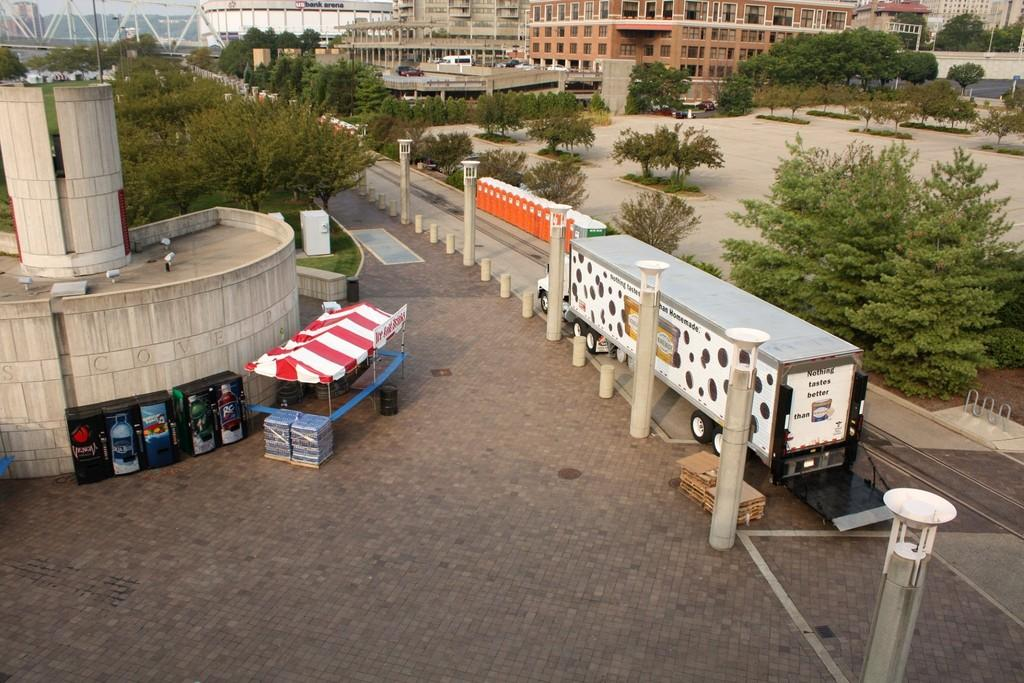What is happening in the image? There is a vehicle moving on the road in the image. What can be seen in the image besides the vehicle? There is a red tent, black color objects, trees, a building, and poles in the background of the image. What type of pies are being sold at the red tent in the image? There is no mention of pies or any food items being sold at the red tent in the image. 